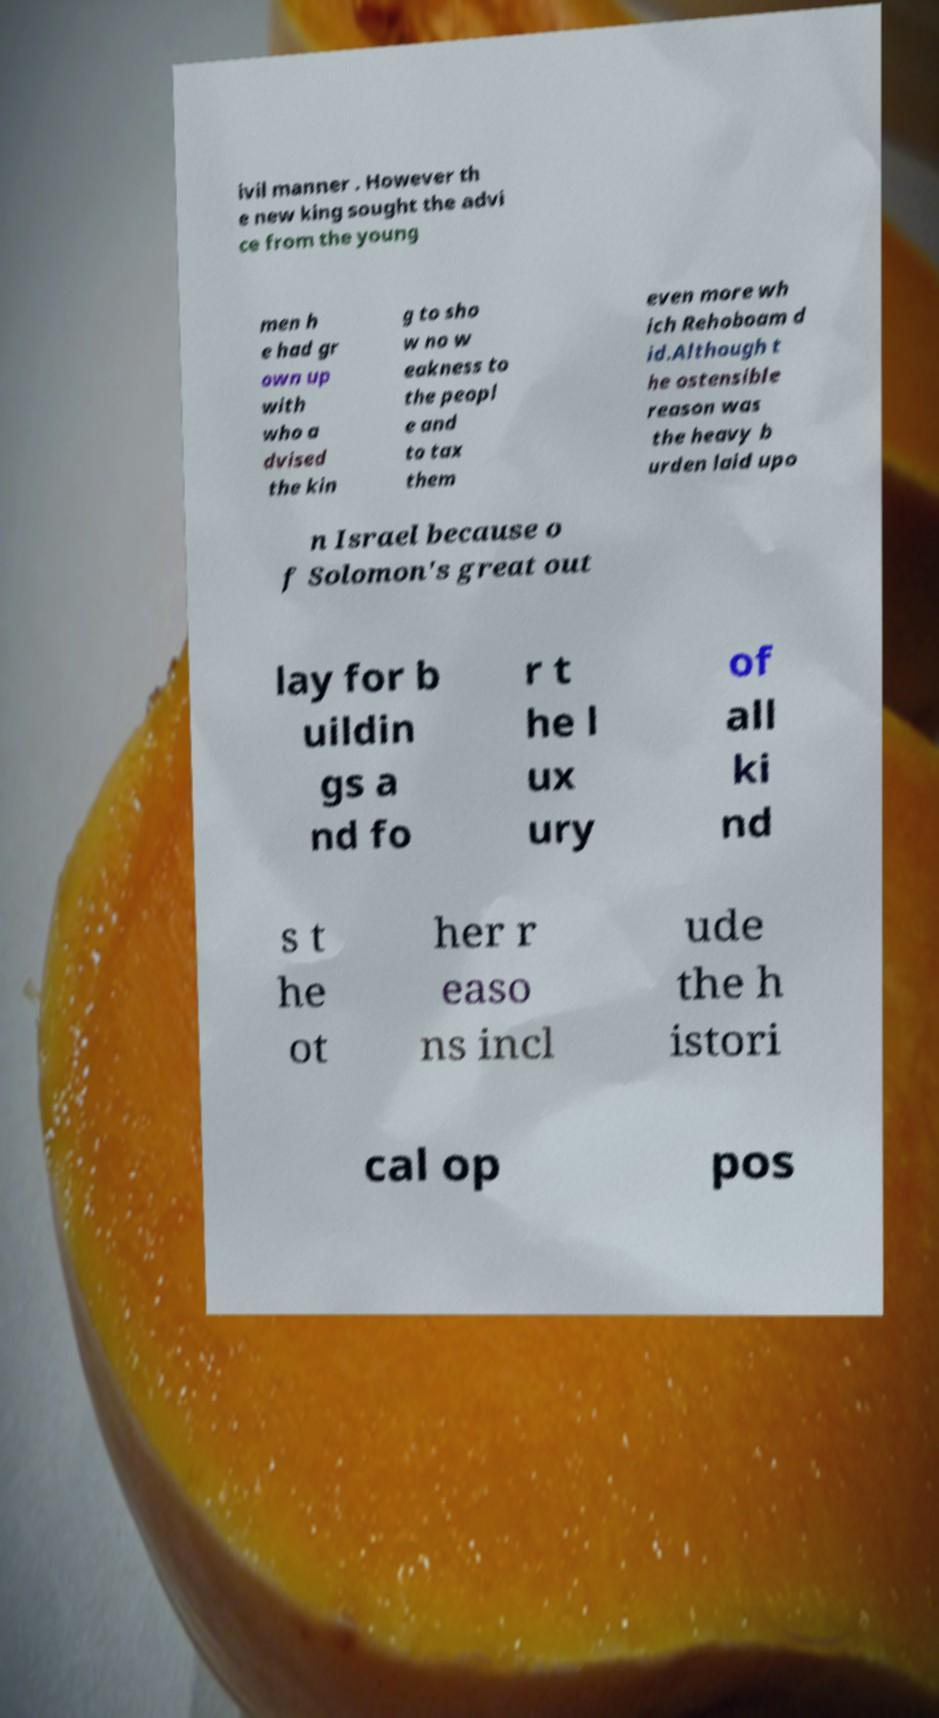Can you read and provide the text displayed in the image?This photo seems to have some interesting text. Can you extract and type it out for me? ivil manner . However th e new king sought the advi ce from the young men h e had gr own up with who a dvised the kin g to sho w no w eakness to the peopl e and to tax them even more wh ich Rehoboam d id.Although t he ostensible reason was the heavy b urden laid upo n Israel because o f Solomon's great out lay for b uildin gs a nd fo r t he l ux ury of all ki nd s t he ot her r easo ns incl ude the h istori cal op pos 